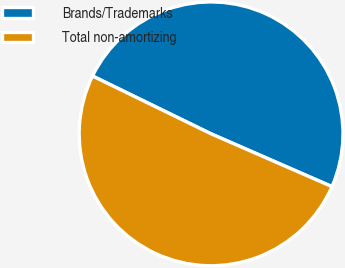Convert chart to OTSL. <chart><loc_0><loc_0><loc_500><loc_500><pie_chart><fcel>Brands/Trademarks<fcel>Total non-amortizing<nl><fcel>49.33%<fcel>50.67%<nl></chart> 